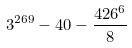Convert formula to latex. <formula><loc_0><loc_0><loc_500><loc_500>3 ^ { 2 6 9 } - 4 0 - \frac { 4 2 6 ^ { 6 } } { 8 }</formula> 